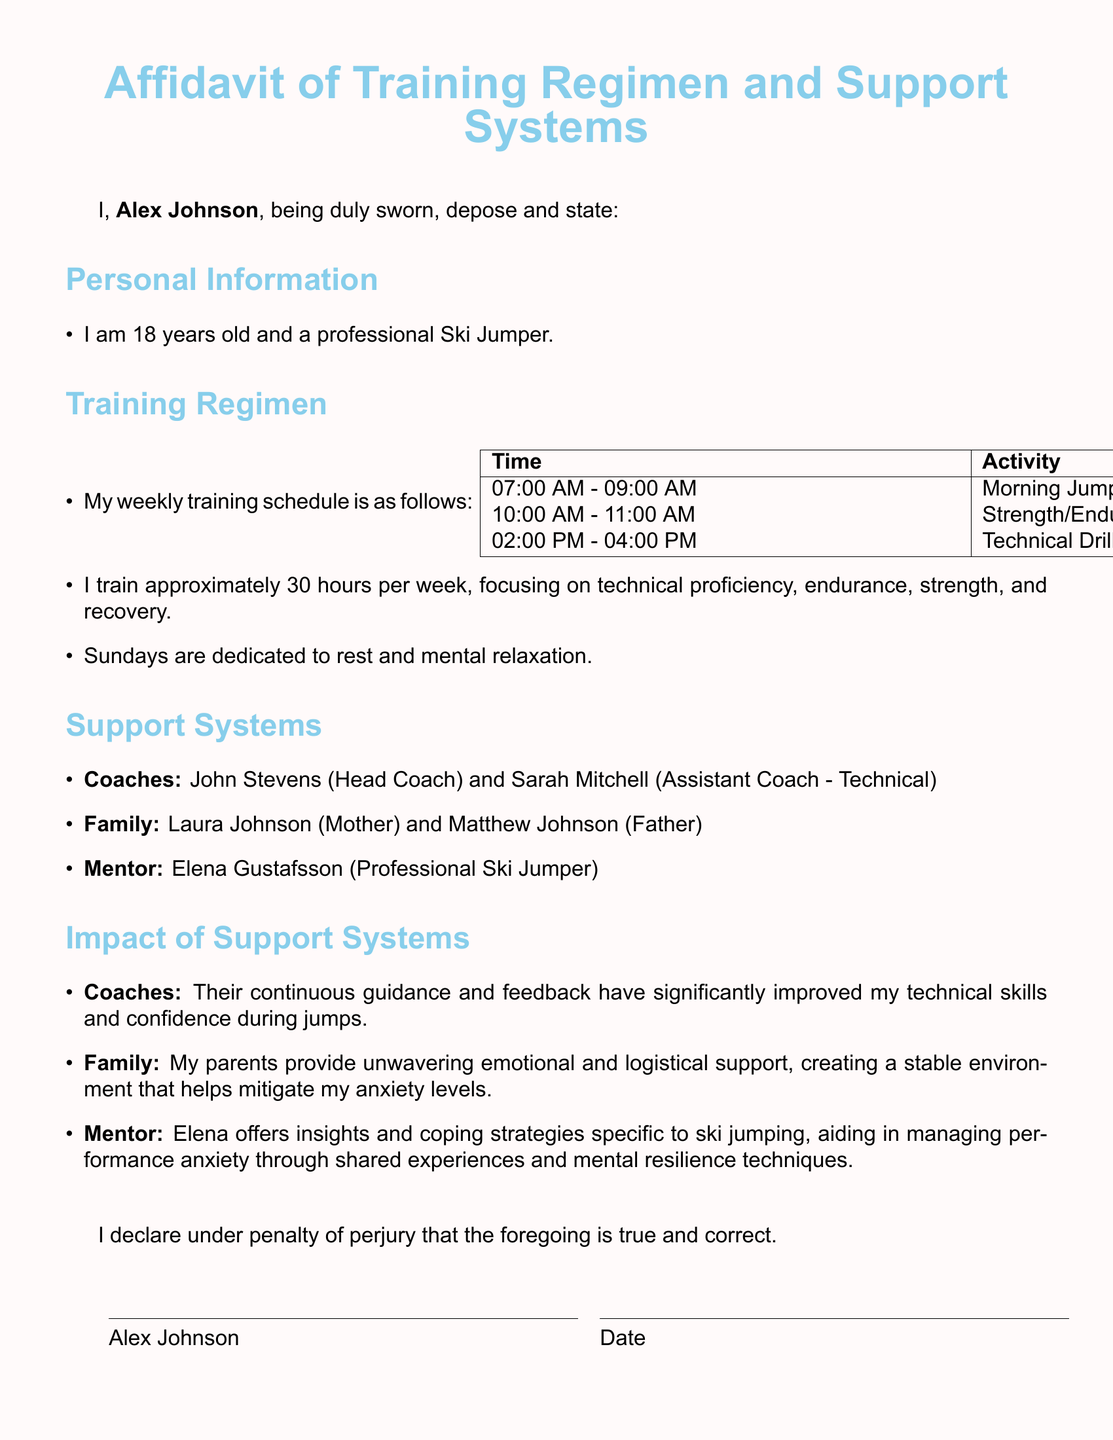What is the name of the head coach? The head coach is listed in the document under Support Systems as John Stevens.
Answer: John Stevens How many hours does Alex train per week? The weekly training hours are specifically stated in the Training Regimen section as approximately 30 hours.
Answer: 30 hours What day is dedicated to rest? The document mentions that Sundays are dedicated to rest and mental relaxation in the Training Regimen section.
Answer: Sundays Who is Alex's mentor? The mentor is identified in the Support Systems section as Elena Gustafsson.
Answer: Elena Gustafsson What type of training occurs from 10:00 AM to 11:00 AM? The training activity from 10:00 AM to 11:00 AM is specified as Strength/Endurance Training in the Training Regimen section.
Answer: Strength/Endurance Training How old is Alex? The document states that Alex is 18 years old in the Personal Information section.
Answer: 18 years old What role does Elena Gustafsson play in Alex's training? Elena is referenced as a mentor who provides coping strategies and insights for managing performance anxiety.
Answer: Mentor What are the two main types of training focus mentioned? The document highlights technical proficiency and endurance as two main focuses among others in the Training Regimen section.
Answer: Technical proficiency, endurance What is the purpose of the affidavit? The document serves to outline Alex's training regimen and support systems and their impact on performance and anxiety levels.
Answer: Outline training and support systems 